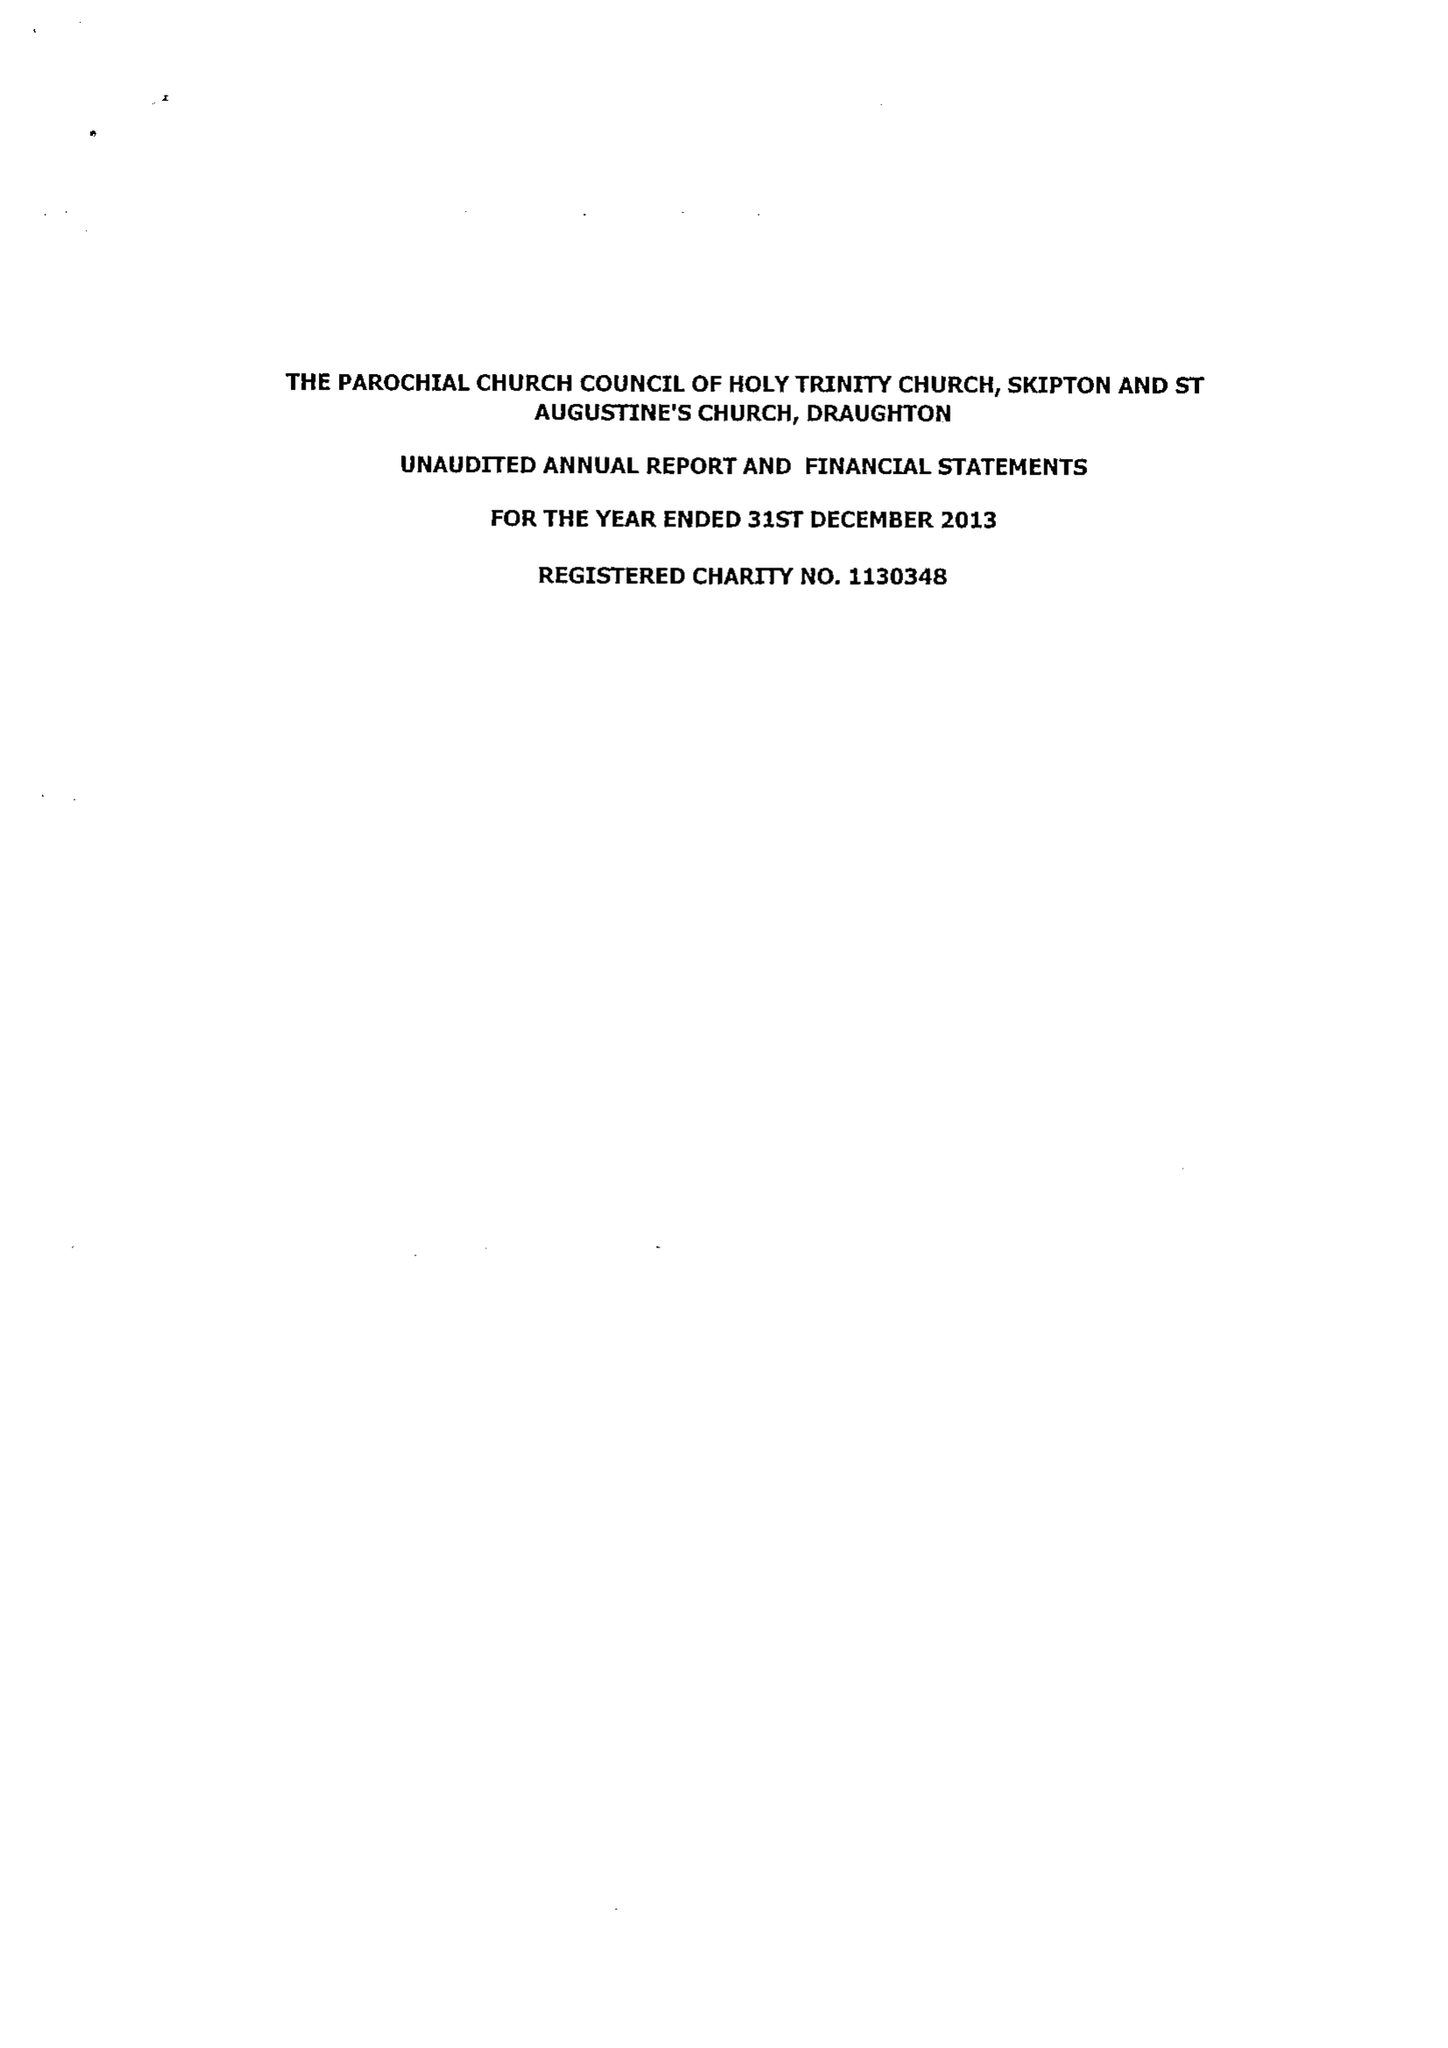What is the value for the address__postcode?
Answer the question using a single word or phrase. BD23 1LY 